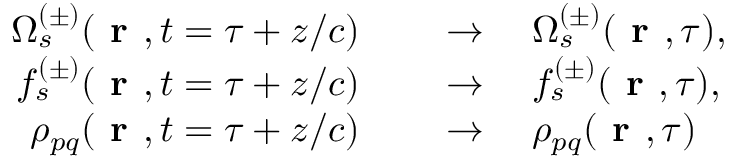<formula> <loc_0><loc_0><loc_500><loc_500>\begin{array} { r l } { \Omega _ { s } ^ { ( \pm ) } ( r , t = \tau + z / c ) \quad } & \to \quad \Omega _ { s } ^ { ( \pm ) } ( r , \tau ) , } \\ { f _ { s } ^ { ( \pm ) } ( r , t = \tau + z / c ) \quad } & \to \quad f _ { s } ^ { ( \pm ) } ( r , \tau ) , } \\ { \rho _ { p q } ( r , t = \tau + z / c ) \quad } & \to \quad \rho _ { p q } ( r , \tau ) } \end{array}</formula> 